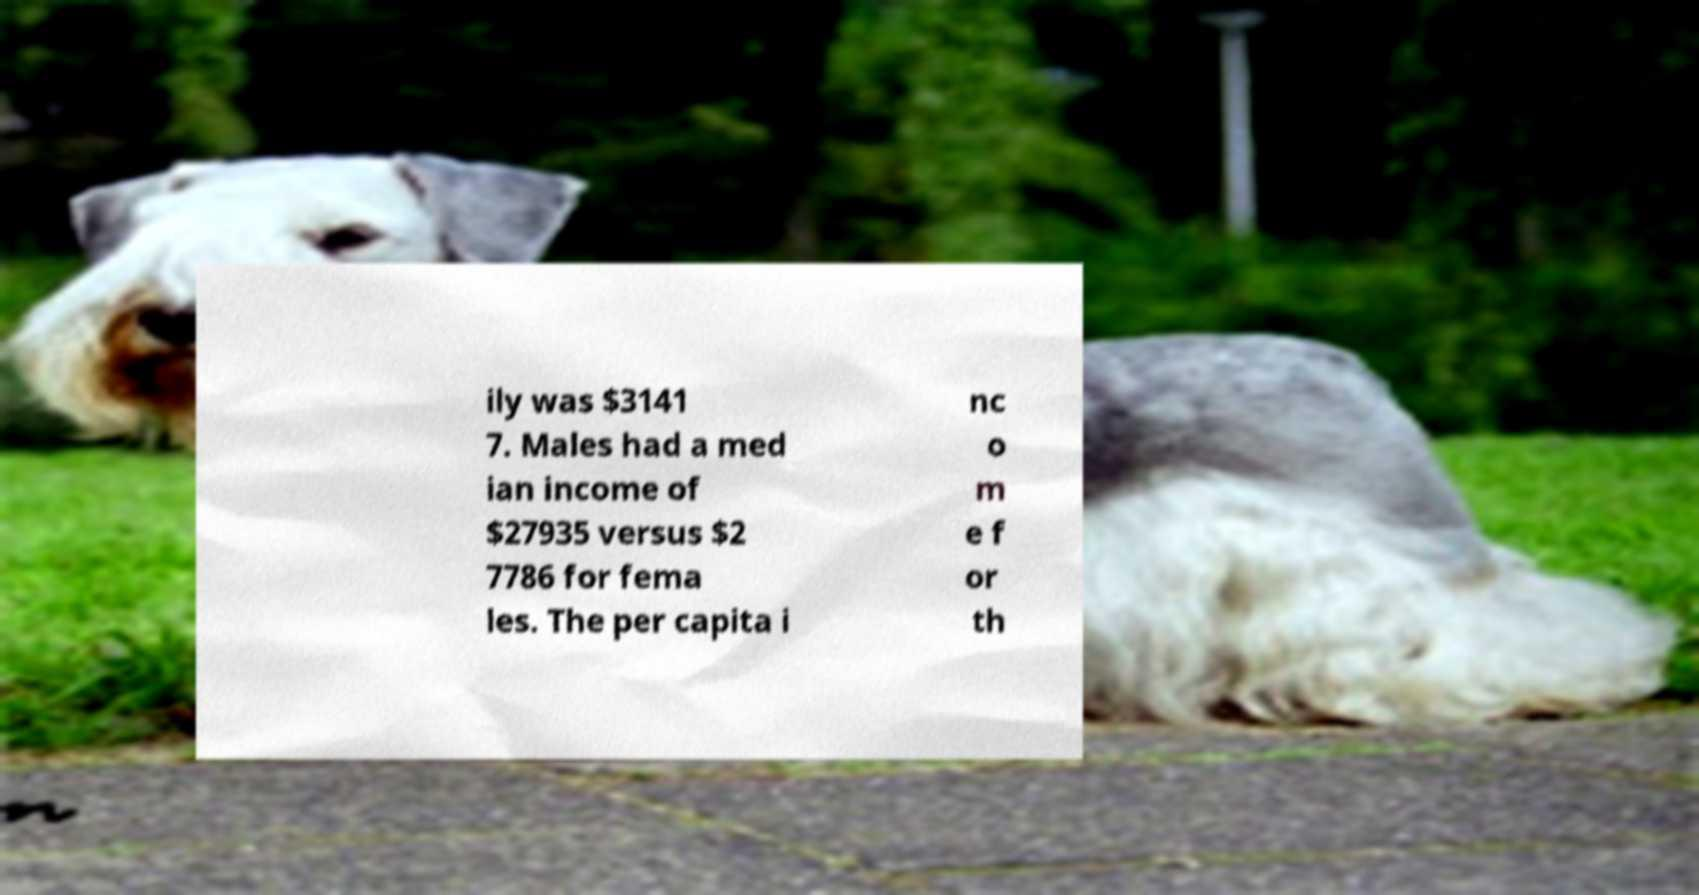There's text embedded in this image that I need extracted. Can you transcribe it verbatim? ily was $3141 7. Males had a med ian income of $27935 versus $2 7786 for fema les. The per capita i nc o m e f or th 